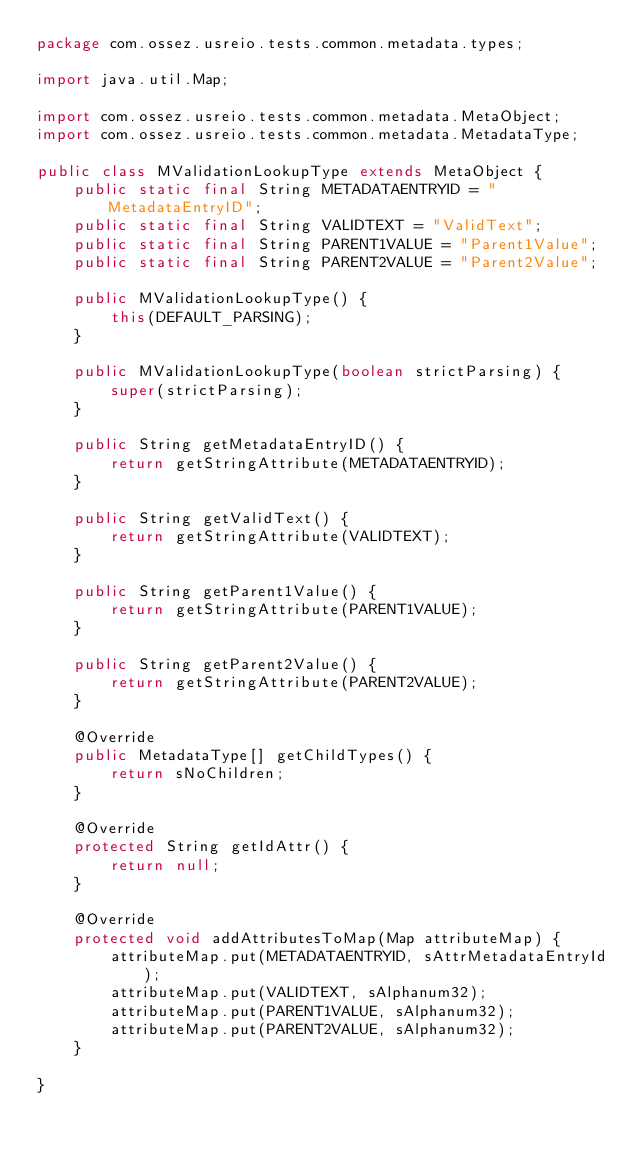Convert code to text. <code><loc_0><loc_0><loc_500><loc_500><_Java_>package com.ossez.usreio.tests.common.metadata.types;

import java.util.Map;

import com.ossez.usreio.tests.common.metadata.MetaObject;
import com.ossez.usreio.tests.common.metadata.MetadataType;

public class MValidationLookupType extends MetaObject {
	public static final String METADATAENTRYID = "MetadataEntryID";
	public static final String VALIDTEXT = "ValidText";
	public static final String PARENT1VALUE = "Parent1Value";
	public static final String PARENT2VALUE = "Parent2Value";

	public MValidationLookupType() {
		this(DEFAULT_PARSING);
	}

	public MValidationLookupType(boolean strictParsing) {
		super(strictParsing);
	}

	public String getMetadataEntryID() {
		return getStringAttribute(METADATAENTRYID);
	}

	public String getValidText() {
		return getStringAttribute(VALIDTEXT);
	}

	public String getParent1Value() {
		return getStringAttribute(PARENT1VALUE);
	}

	public String getParent2Value() {
		return getStringAttribute(PARENT2VALUE);
	}

	@Override
	public MetadataType[] getChildTypes() {
		return sNoChildren;
	}

	@Override
	protected String getIdAttr() {
		return null;
	}

	@Override
	protected void addAttributesToMap(Map attributeMap) {
		attributeMap.put(METADATAENTRYID, sAttrMetadataEntryId);
		attributeMap.put(VALIDTEXT, sAlphanum32);
		attributeMap.put(PARENT1VALUE, sAlphanum32);
		attributeMap.put(PARENT2VALUE, sAlphanum32);
	}

}
</code> 